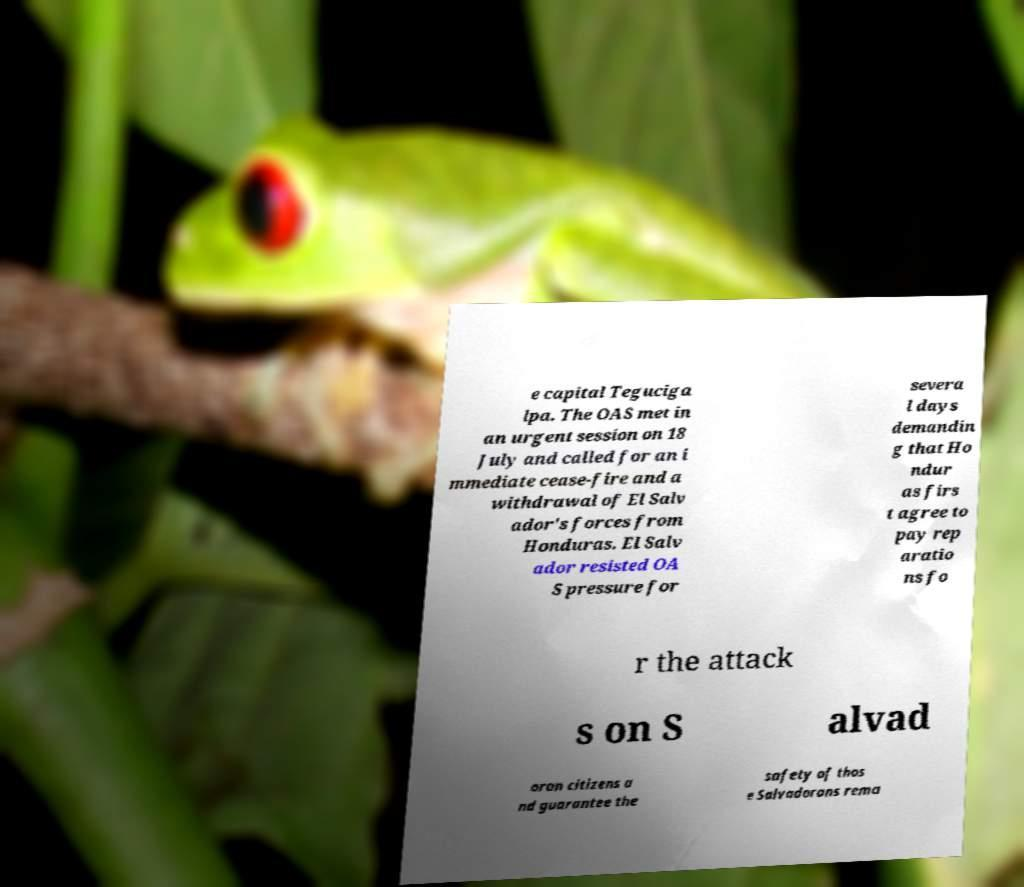I need the written content from this picture converted into text. Can you do that? e capital Teguciga lpa. The OAS met in an urgent session on 18 July and called for an i mmediate cease-fire and a withdrawal of El Salv ador's forces from Honduras. El Salv ador resisted OA S pressure for severa l days demandin g that Ho ndur as firs t agree to pay rep aratio ns fo r the attack s on S alvad oran citizens a nd guarantee the safety of thos e Salvadorans rema 